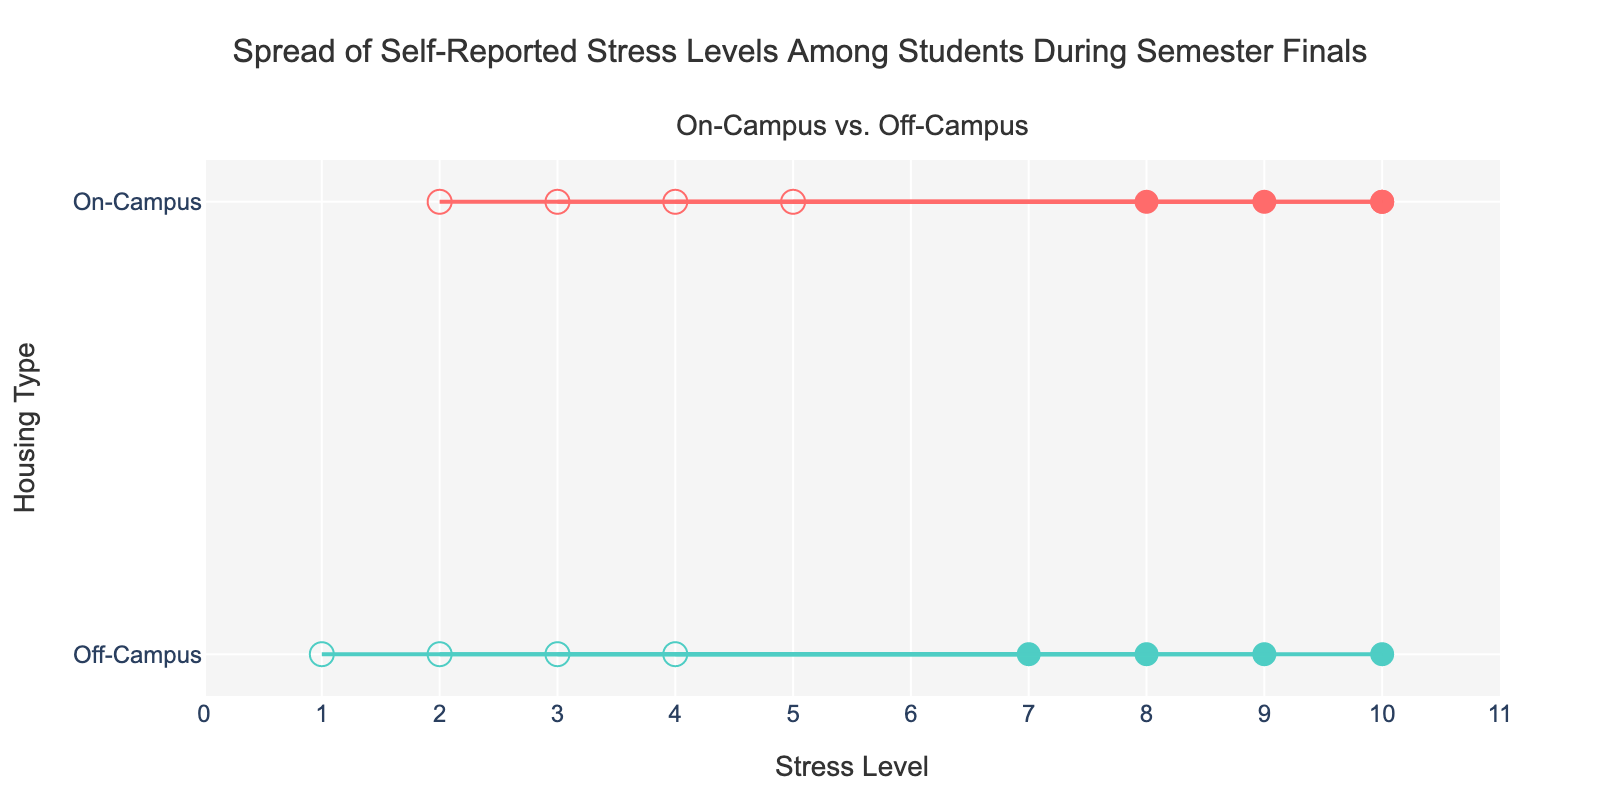What is the range of self-reported stress levels for on-campus students? The range for on-campus students can be observed by looking at the minimum and maximum stress levels across all on-campus data points. The minimum stress level is 2 and the maximum is 10, so the range is 10 - 2 = 8.
Answer: 2 to 10 How do the average minimum stress levels compare between on-campus and off-campus students? To find the average minimum stress level for each group, sum the minimum stress levels for each group and divide by the number of data points. On-Campus: (2+3+4+5)/4=3.5; Off-Campus: (1+2+3+4)/4=2.5. The comparison shows that on-campus students have a higher average minimum stress level than off-campus students.
Answer: On-campus average 3.5, off-campus average 2.5 Which housing type has a wider spread of self-reported stress levels? A wider spread is indicated by a greater range between the minimum and maximum stress levels. On-campus students have a range of 8 (10-2) and off-campus students have a range of 9 (10-1). Therefore, off-campus students exhibit a wider spread of stress levels.
Answer: Off-campus What is the maximum stress level reported by off-campus students? The maximum stress level for off-campus students can be found by identifying the highest MaxStressLevel value for the Off-Campus category which is 10.
Answer: 10 Between on-campus and off-campus students, which group has the lowest reported stress level, and what is that level? The lowest reported stress level for on-campus students is 2, while for off-campus students it is 1. Therefore, off-campus students report the lowest stress level.
Answer: Off-campus, 1 How many different minimum stress levels are there for off-campus students? To determine the number of different minimum stress levels for off-campus students, count the unique MinStressLevel values. The unique values are 1, 2, 3, and 4, thus there are 4 different minimum stress levels.
Answer: 4 Which group has less variation in their maximum reported stress levels? Variation can be assessed by the spread of maximum stress levels. On-campus maximum stress levels are 10, 9, 8, 10, with a spread of 10-8=2. Off-campus maximum stress levels are 7, 8, 9, 10, with a spread of 10-7=3. Therefore, on-campus students show less variation.
Answer: On-campus Are there any instances where on-campus students reported a lower minimum stress level than all off-campus students? By comparing minimum stress levels, the lowest on-campus stress level is 2, whereas the lowest off-campus stress level is 1. Therefore, there are no instances where an on-campus student's minimum stress level is lower than all off-campus students.
Answer: No Do on-campus or off-campus students report more consistent maximum stress levels? To determine which group reports more consistent maximum stress levels, look at the range of maximum levels. On-campus maximum stress levels range from 8 to 10 (range=2), while off-campus maximum stress levels range from 7 to 10 (range=3). Therefore, on-campus students have more consistent maximum stress levels.
Answer: On-campus 